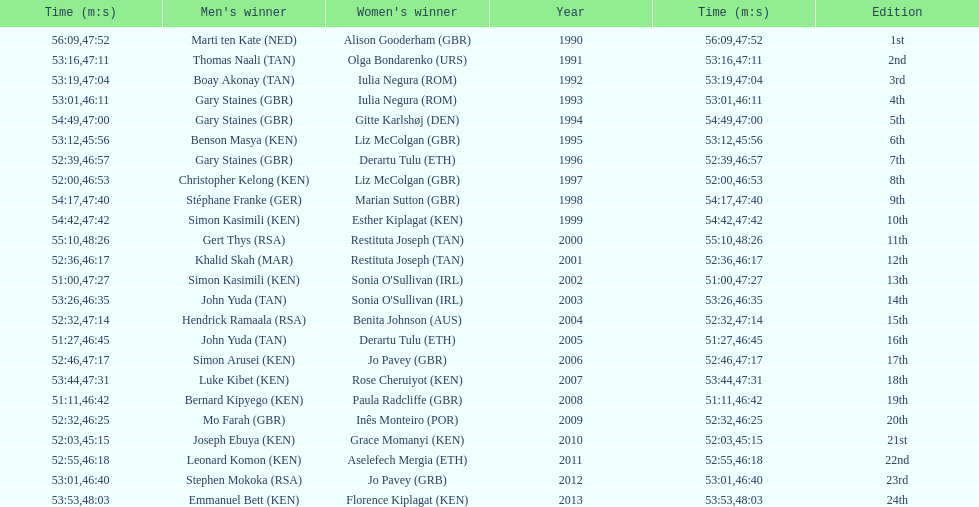Number of men's winners with a finish time under 46:58 12. 